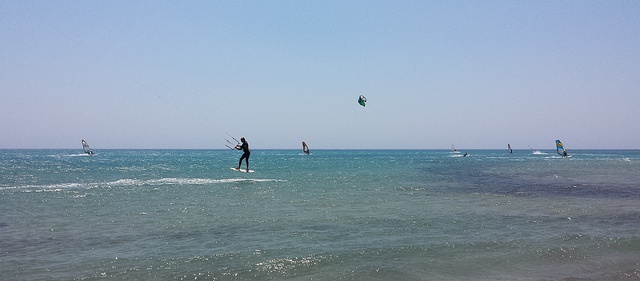Describe the objects in this image and their specific colors. I can see people in darkgray, black, gray, and blue tones, surfboard in darkgray, teal, gray, and lightgray tones, kite in darkgray, black, gray, and teal tones, and people in darkgray, darkblue, black, and teal tones in this image. 